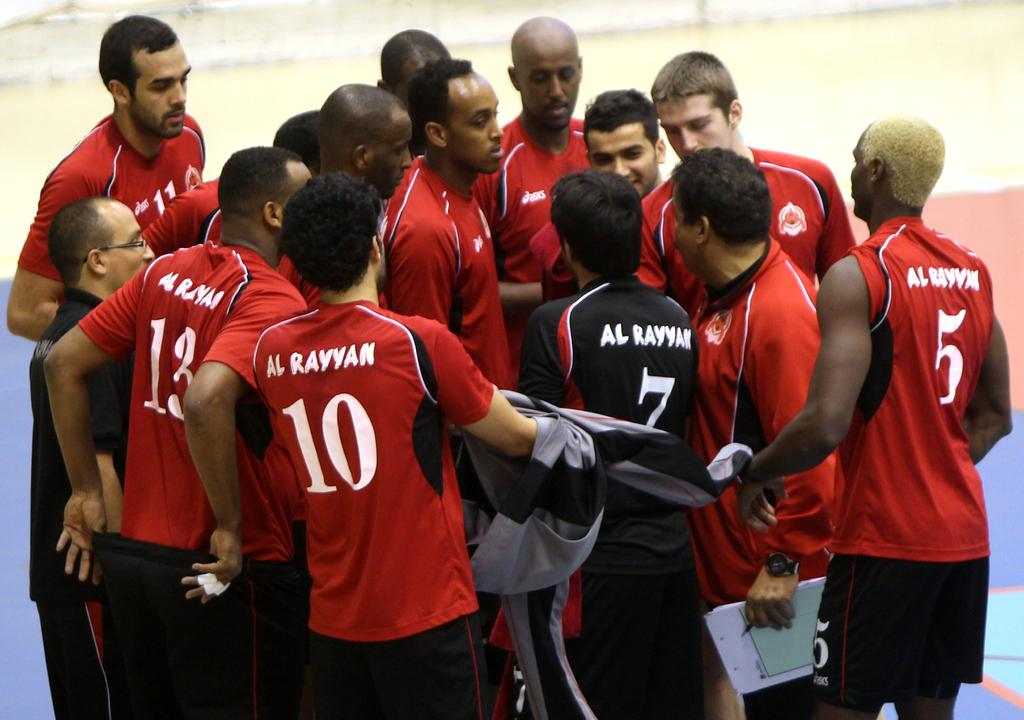<image>
Provide a brief description of the given image. The player wearing black is wearing the number 7 